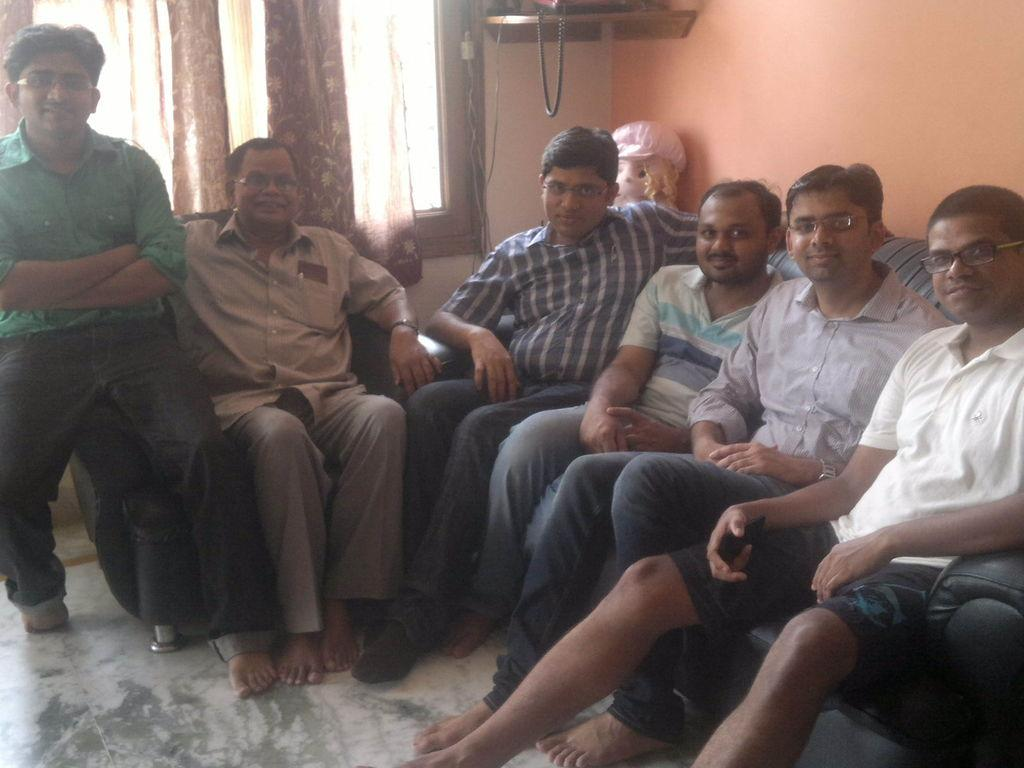How many people are in the image? There is a group of people in the image. What are the people doing in the image? The people are sitting on a couch and a chair. What object can be seen behind the people? There is a toy visible behind the people. What type of window treatment is present in the image? There are curtains in the image. What type of architectural feature is visible in the image? There is a wall in the image. What type of juice is being served to the people in the image? There is no juice present in the image; it only shows a group of people sitting on a couch and a chair with a toy visible behind them. 